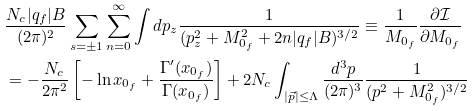<formula> <loc_0><loc_0><loc_500><loc_500>& \frac { N _ { c } | q _ { f } | B } { ( 2 \pi ) ^ { 2 } } \sum _ { s = \pm 1 } \sum _ { n = 0 } ^ { \infty } \int d p _ { z } \frac { 1 } { ( p _ { z } ^ { 2 } + M _ { 0 _ { f } } ^ { 2 } + 2 n | q _ { f } | B ) ^ { 3 / 2 } } \equiv \frac { 1 } { M _ { 0 _ { f } } } \frac { \partial \mathcal { I } } { \partial M _ { 0 _ { f } } } \\ & = - \frac { N _ { c } } { 2 \pi ^ { 2 } } \left [ - \ln x _ { 0 _ { f } } + \frac { \Gamma ^ { \prime } ( x _ { 0 _ { f } } ) } { \Gamma ( x _ { 0 _ { f } } ) } \right ] + 2 N _ { c } \int _ { | \vec { p } | \leq \Lambda } \frac { d ^ { 3 } p } { ( 2 \pi ) ^ { 3 } } \frac { 1 } { ( p ^ { 2 } + M _ { 0 _ { f } } ^ { 2 } ) ^ { 3 / 2 } }</formula> 